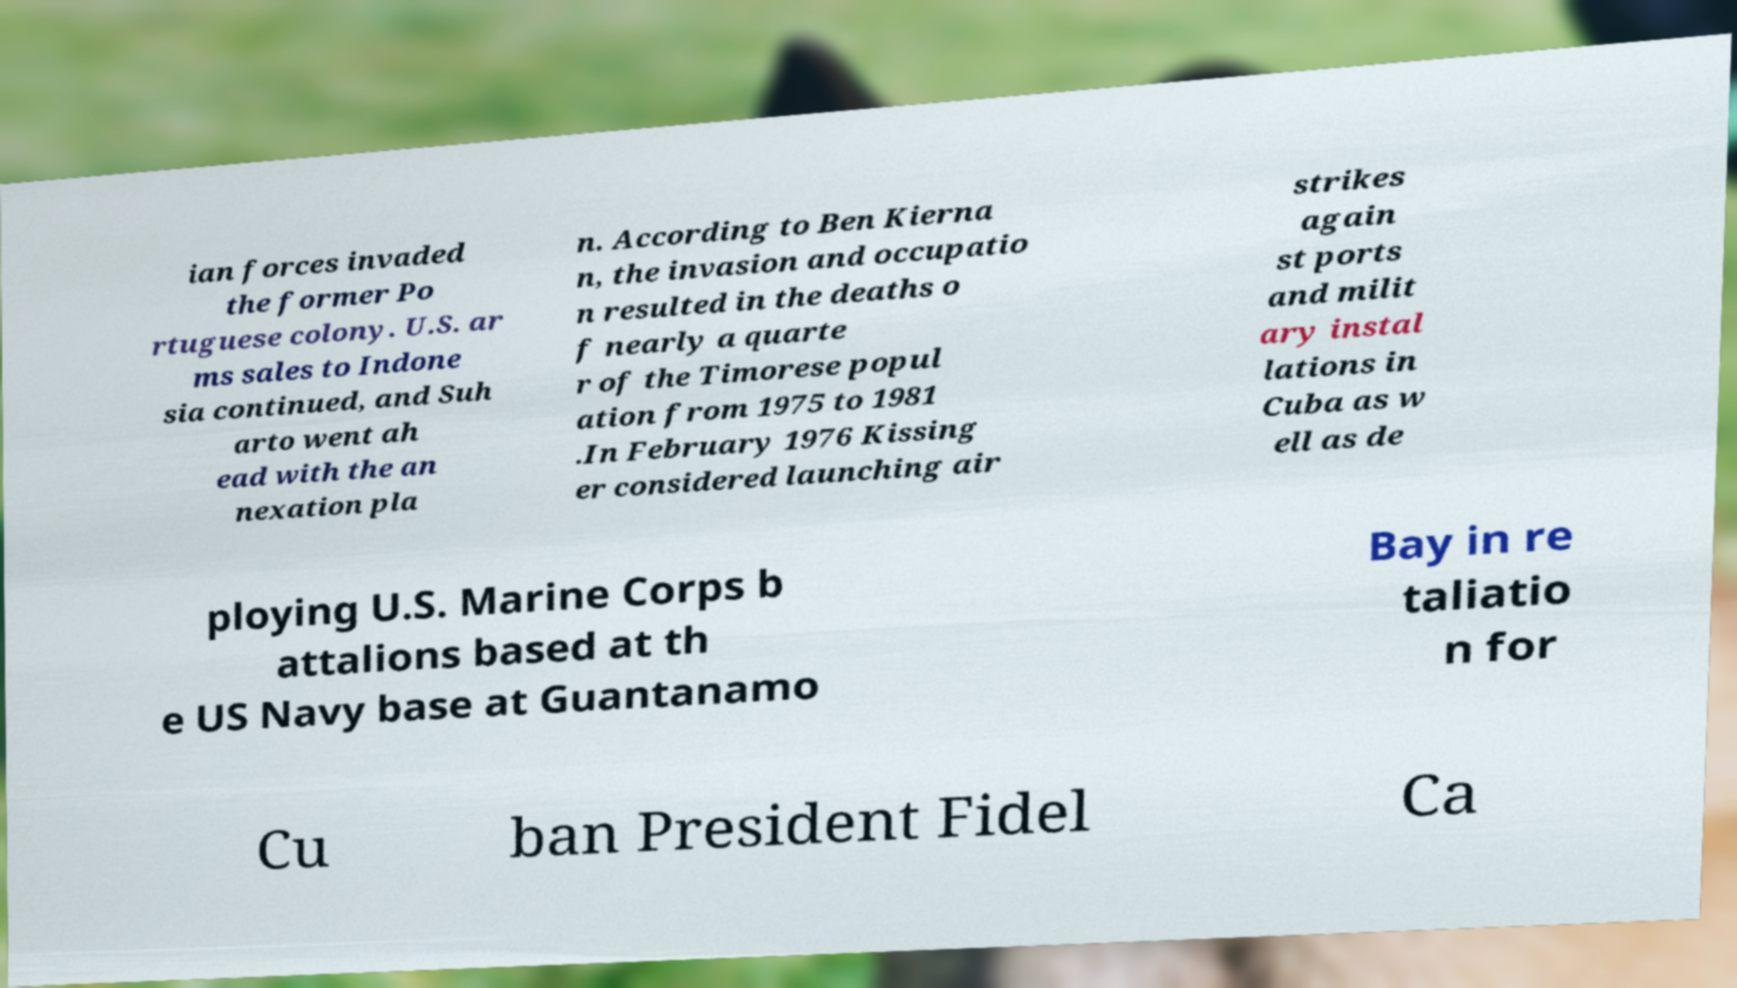What messages or text are displayed in this image? I need them in a readable, typed format. ian forces invaded the former Po rtuguese colony. U.S. ar ms sales to Indone sia continued, and Suh arto went ah ead with the an nexation pla n. According to Ben Kierna n, the invasion and occupatio n resulted in the deaths o f nearly a quarte r of the Timorese popul ation from 1975 to 1981 .In February 1976 Kissing er considered launching air strikes again st ports and milit ary instal lations in Cuba as w ell as de ploying U.S. Marine Corps b attalions based at th e US Navy base at Guantanamo Bay in re taliatio n for Cu ban President Fidel Ca 